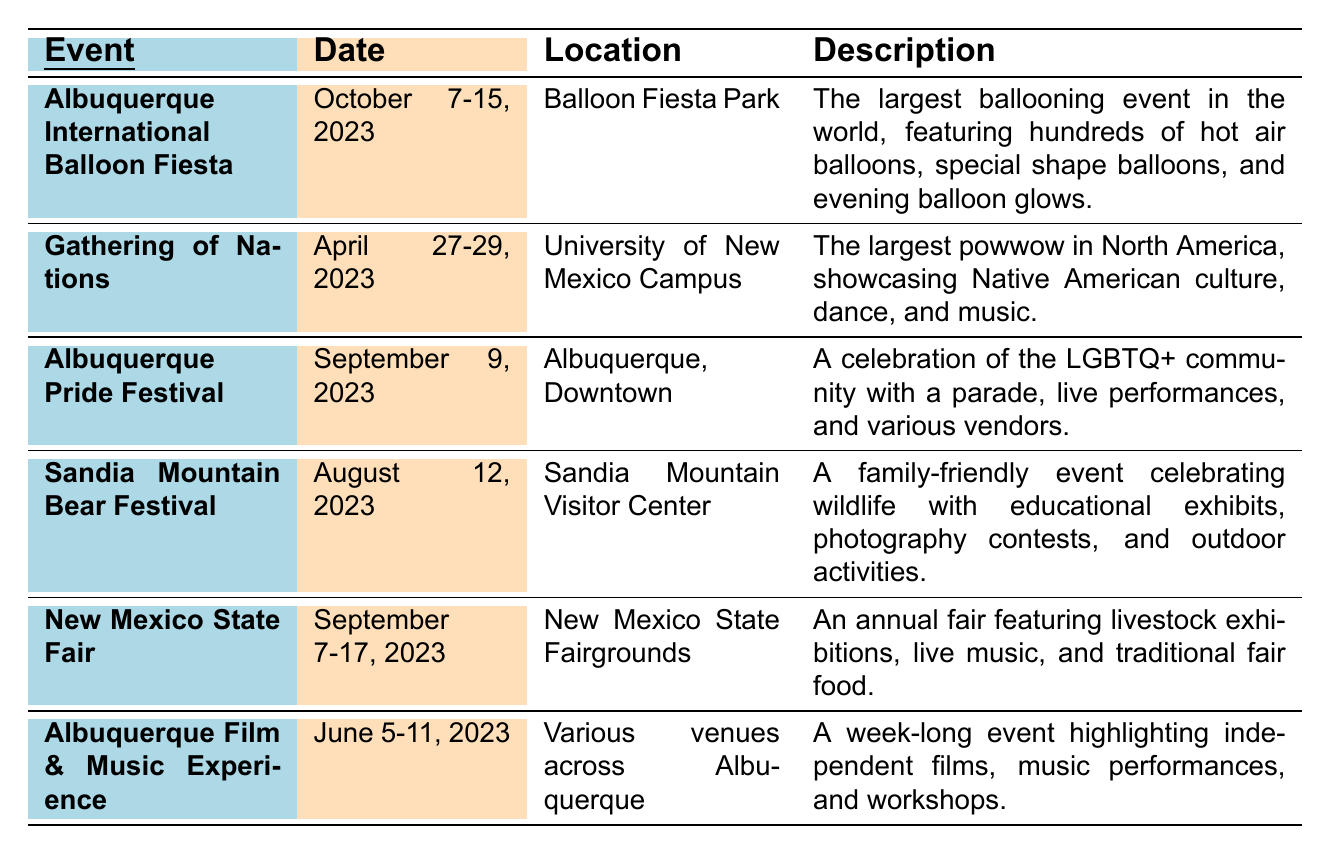What is the date range for the Albuquerque International Balloon Fiesta? The date range for the event is clearly stated in the table under the "Date" column for the Albuquerque International Balloon Fiesta, which is from October 7 to October 15, 2023.
Answer: October 7-15, 2023 Where is the Gathering of Nations being held? The location of the Gathering of Nations is listed in the "Location" column. According to the table, it is held at the University of New Mexico Campus.
Answer: University of New Mexico Campus How many days does the New Mexico State Fair last? The New Mexico State Fair runs from September 7 to September 17, 2023. To find the duration in days, count the number of days from the start to the end date, which is 11 days.
Answer: 11 days Is the Sandia Mountain Bear Festival a family-friendly event? The description for the Sandia Mountain Bear Festival in the table states that it is a family-friendly event, indicating that it is suitable for families and children.
Answer: Yes Which event occurs in September? To find the events in September, look at the "Date" column. Both the Albuquerque Pride Festival on September 9 and the New Mexico State Fair from September 7-17 are in September.
Answer: Albuquerque Pride Festival and New Mexico State Fair What type of performances are featured at the Albuquerque Film & Music Experience? The description of the Albuquerque Film & Music Experience indicates that it highlights independent films and music performances, answering the query about the type of performances.
Answer: Independent films and music performances Which event focuses on Native American culture? The Gathering of Nations is specifically mentioned in the description as the largest powwow in North America that showcases Native American culture, confirming it as the relevant event.
Answer: Gathering of Nations How many events are held in the summer? The summer includes June, July, and August. Only one event, the Albuquerque Film & Music Experience, is listed in June (June 5-11, 2023), and the Sandia Mountain Bear Festival in August (August 12, 2023), making a total of 2 events.
Answer: 2 events What is the primary focus of the Albuquerque Pride Festival? The description indicates that the primary focus of the Albuquerque Pride Festival is to celebrate the LGBTQ+ community through a parade, live performances, and vendors.
Answer: Celebrating LGBTQ+ community Which event has the longest duration? The Albuquerque International Balloon Fiesta lasts for 9 days (October 7-15, 2023), while the others vary in length. The New Mexico State Fair is 11 days, which is longer. Therefore, the New Mexico State Fair has the longest duration.
Answer: New Mexico State Fair 